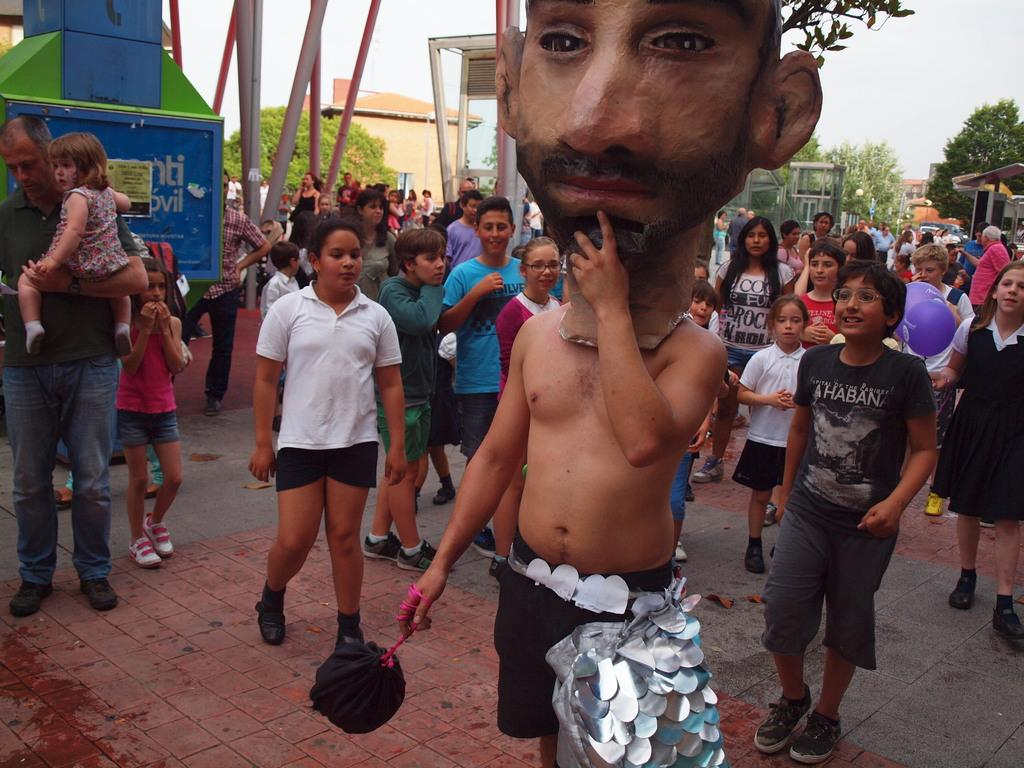How many people are present in the image? There are many persons in the image. Can you describe the kids in the image? There are kids standing in the image. Where is the person wearing a mask located in the image? The person wearing a mask is on the right side of the image. What type of natural vegetation is visible in the image? There are trees in the image. What type of man-made structures can be seen in the image? There are buildings in the image. What is the condition of the sky in the image? The sky is clear in the image. What type of shoes is the engine wearing in the image? There is no engine or shoes present in the image. Can you describe the nose of the person standing on the left side of the image? There is no person standing on the left side of the image, and therefore no nose to describe. 